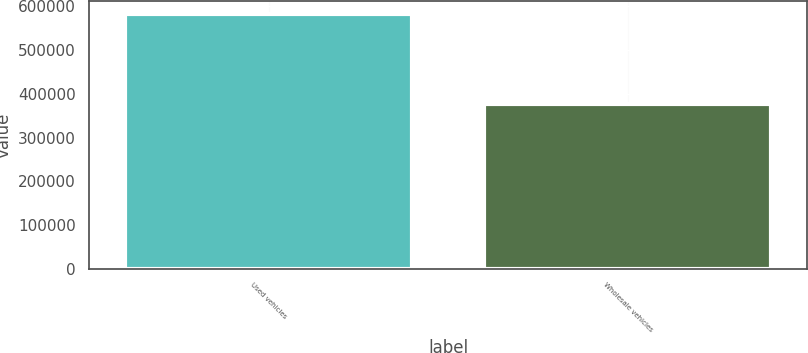<chart> <loc_0><loc_0><loc_500><loc_500><bar_chart><fcel>Used vehicles<fcel>Wholesale vehicles<nl><fcel>582282<fcel>376186<nl></chart> 